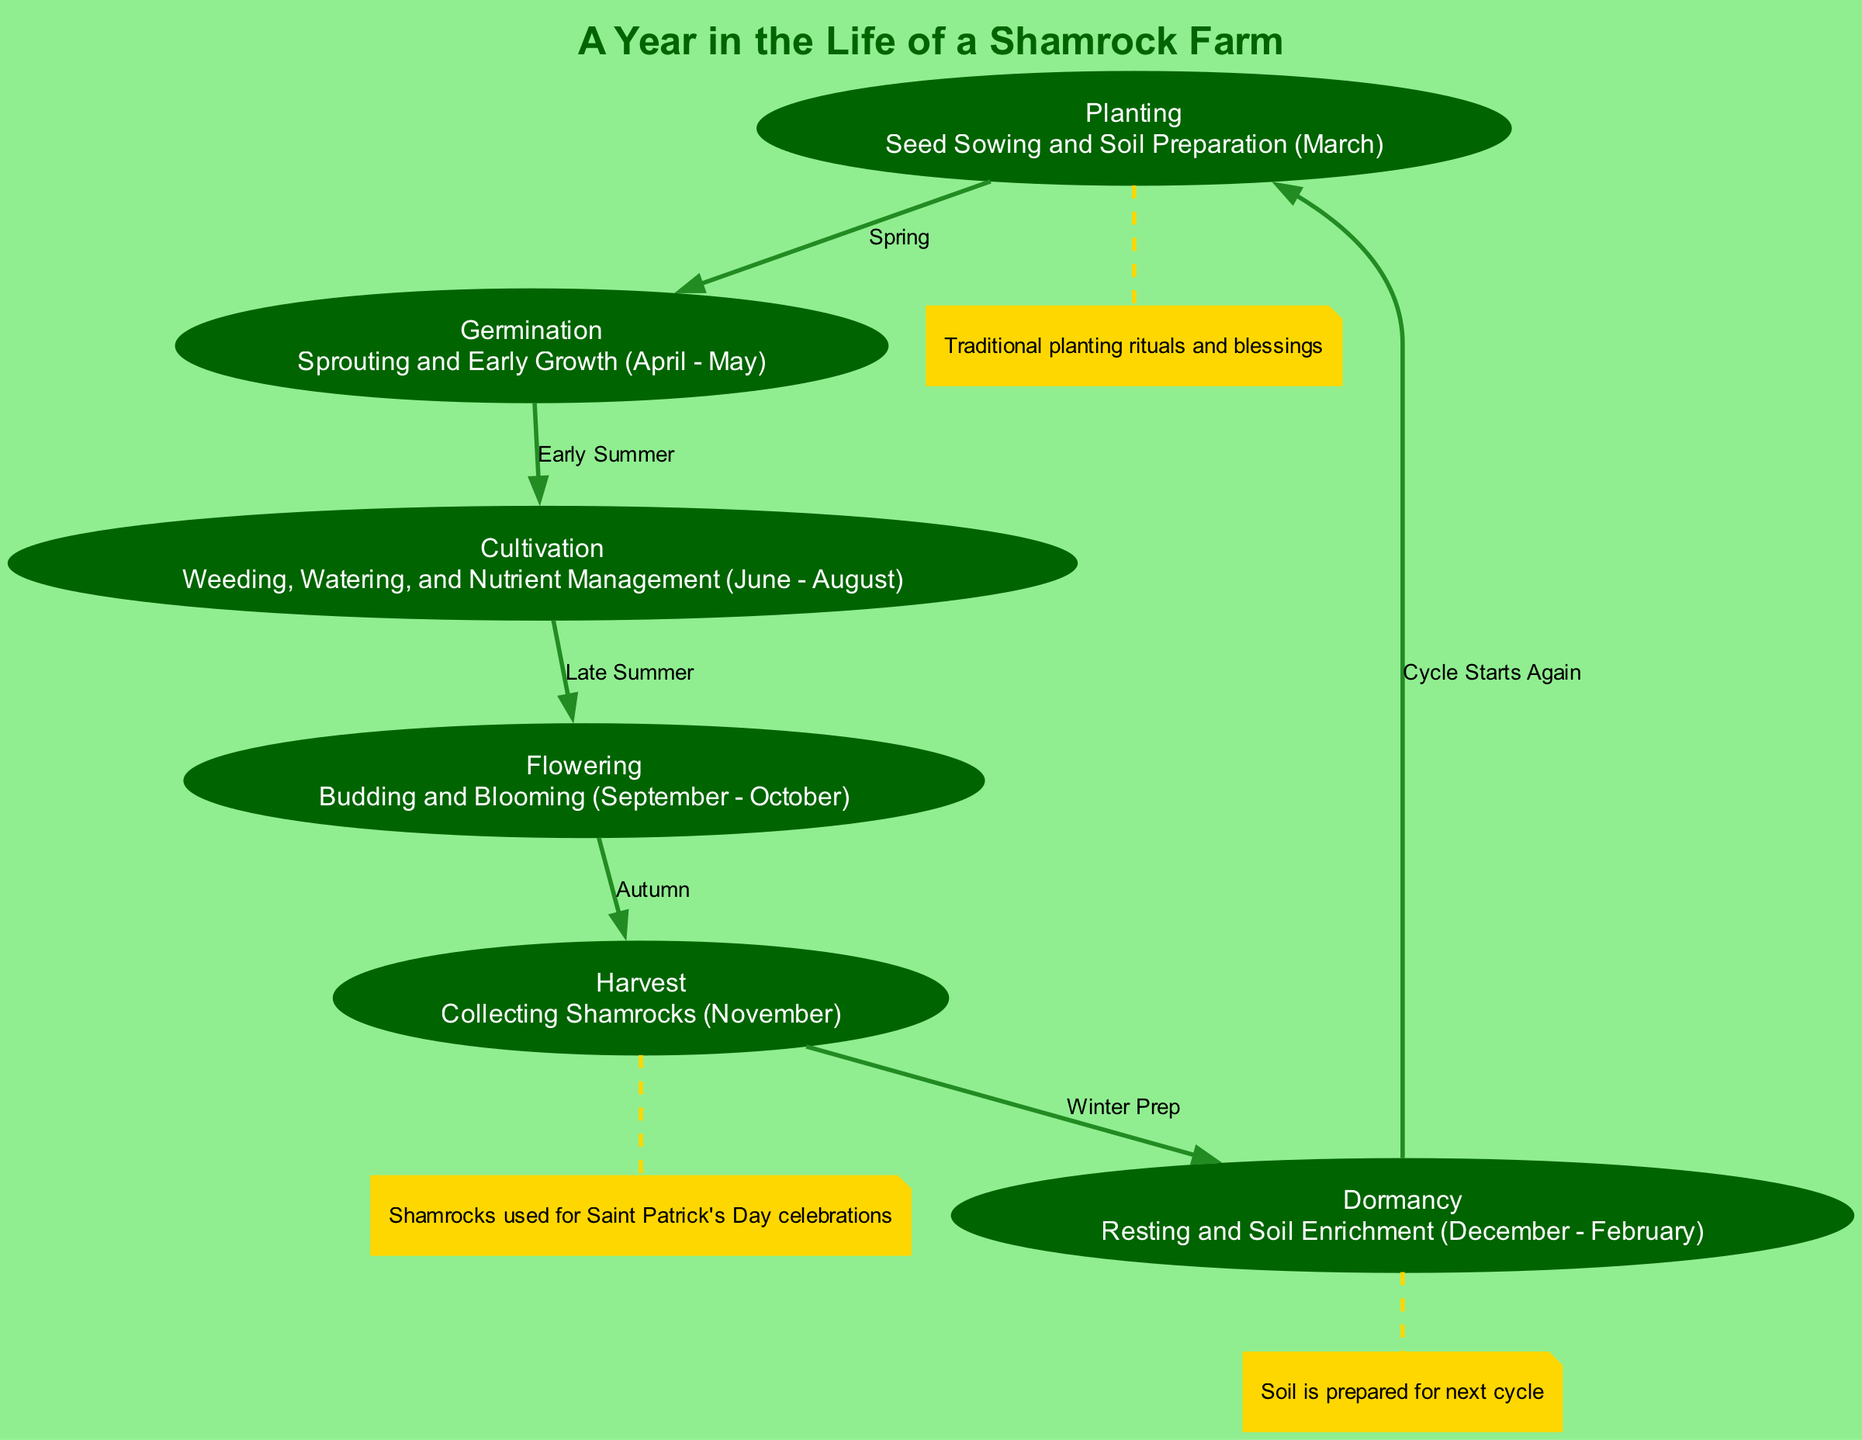What is the first stage of the shamrock farming cycle? The diagram indicates that the first stage is "Planting," where seed sowing and soil preparation occurs in March.
Answer: Planting During which months does germination take place? The diagram shows that germination occurs from April to May.
Answer: April - May How many total stages are there in the shamrock farming cycle? By counting the nodes in the diagram, there are six stages: Planting, Germination, Cultivation, Flowering, Harvest, and Dormancy.
Answer: Six What season is associated with cultivation? The diagram specifies that cultivation takes place during the summer months, indicating that it aligns with early summer, after germination.
Answer: Early Summer Which cultural significance is mentioned related to the harvest stage? The diagram notes that shamrocks collected during the harvest are used for Saint Patrick's Day celebrations, showcasing their cultural importance.
Answer: Saint Patrick's Day celebrations What happens in the dormancy stage? The diagram indicates that during dormancy, the soil is enriched and prepared for the next cycle, providing a resting period for the shamrocks.
Answer: Resting and Soil Enrichment What is the relationship between the flowering and harvest stages? The diagram illustrates that flowering leads directly to the harvest stage, indicating a transition from budding and blooming in autumn to collecting shamrocks in November.
Answer: Autumn What is the purpose of traditional planting rituals? According to the annotations in the diagram, traditional planting rituals and blessings are conducted during the planting stage to honor the process.
Answer: Traditional planting rituals and blessings What is the title of this diagram? The title specified in the diagram is "A Year in the Life of a Shamrock Farm," which encapsulates the overall theme of the farming cycle.
Answer: A Year in the Life of a Shamrock Farm 